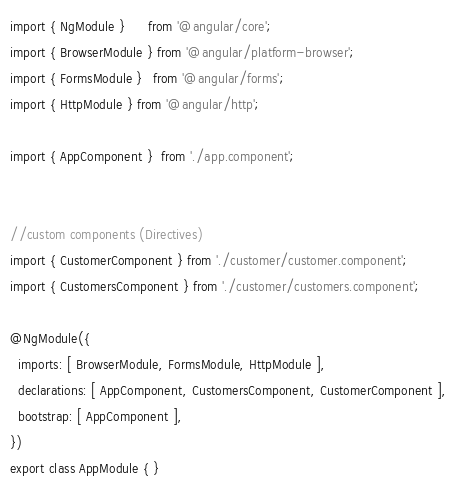<code> <loc_0><loc_0><loc_500><loc_500><_TypeScript_>import { NgModule }      from '@angular/core';
import { BrowserModule } from '@angular/platform-browser';
import { FormsModule }   from '@angular/forms';
import { HttpModule } from '@angular/http';

import { AppComponent }  from './app.component';


//custom components (Directives)
import { CustomerComponent } from './customer/customer.component';
import { CustomersComponent } from './customer/customers.component';

@NgModule({
  imports: [ BrowserModule, FormsModule, HttpModule ],
  declarations: [ AppComponent, CustomersComponent, CustomerComponent ],
  bootstrap: [ AppComponent ],
})
export class AppModule { }
</code> 